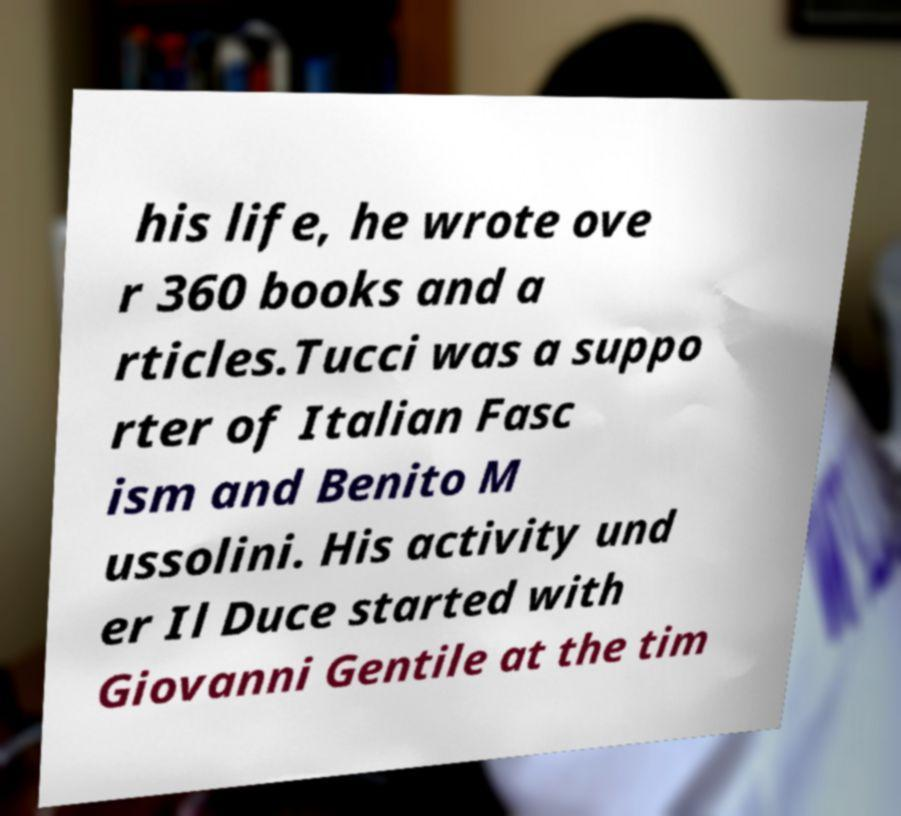Could you assist in decoding the text presented in this image and type it out clearly? his life, he wrote ove r 360 books and a rticles.Tucci was a suppo rter of Italian Fasc ism and Benito M ussolini. His activity und er Il Duce started with Giovanni Gentile at the tim 